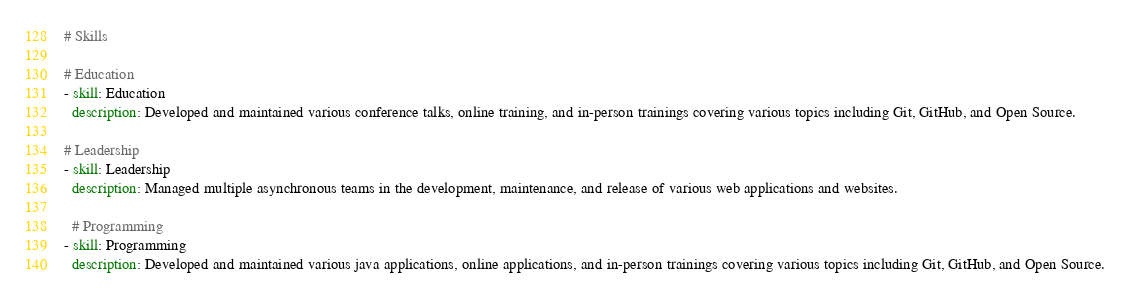Convert code to text. <code><loc_0><loc_0><loc_500><loc_500><_YAML_># Skills

# Education
- skill: Education
  description: Developed and maintained various conference talks, online training, and in-person trainings covering various topics including Git, GitHub, and Open Source.

# Leadership
- skill: Leadership
  description: Managed multiple asynchronous teams in the development, maintenance, and release of various web applications and websites.
  
  # Programming
- skill: Programming
  description: Developed and maintained various java applications, online applications, and in-person trainings covering various topics including Git, GitHub, and Open Source.
</code> 